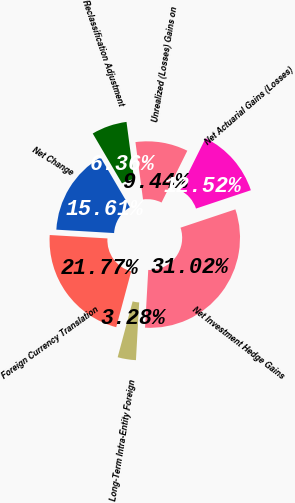Convert chart to OTSL. <chart><loc_0><loc_0><loc_500><loc_500><pie_chart><fcel>Unrealized (Losses) Gains on<fcel>Reclassification Adjustment<fcel>Net Change<fcel>Foreign Currency Translation<fcel>Long-Term Intra-Entity Foreign<fcel>Net Investment Hedge Gains<fcel>Net Actuarial Gains (Losses)<nl><fcel>9.44%<fcel>6.36%<fcel>15.61%<fcel>21.77%<fcel>3.28%<fcel>31.02%<fcel>12.52%<nl></chart> 